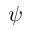Convert formula to latex. <formula><loc_0><loc_0><loc_500><loc_500>\psi</formula> 